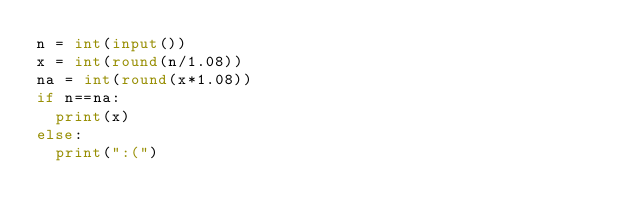<code> <loc_0><loc_0><loc_500><loc_500><_Python_>n = int(input())
x = int(round(n/1.08))
na = int(round(x*1.08))
if n==na:
  print(x)
else:
  print(":(")</code> 